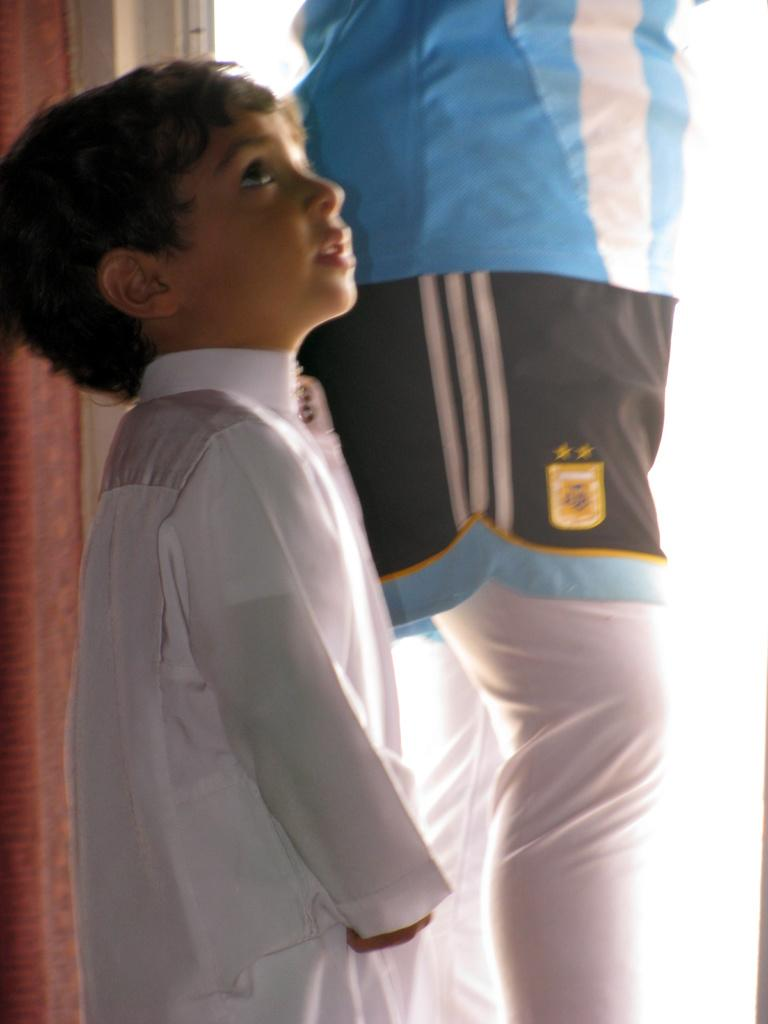Who are the two people in the center of the image? There is a man and a boy standing in the center of the image. What can be seen in the background of the image? There is a wall and a door in the background of the image. What grade is the doll in the image? There is no doll present in the image, so it is not possible to determine the grade of a doll. 